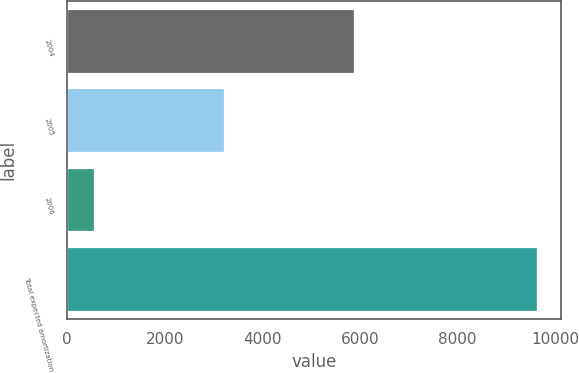<chart> <loc_0><loc_0><loc_500><loc_500><bar_chart><fcel>2004<fcel>2005<fcel>2006<fcel>Total expected amortization<nl><fcel>5873<fcel>3214<fcel>547<fcel>9634<nl></chart> 